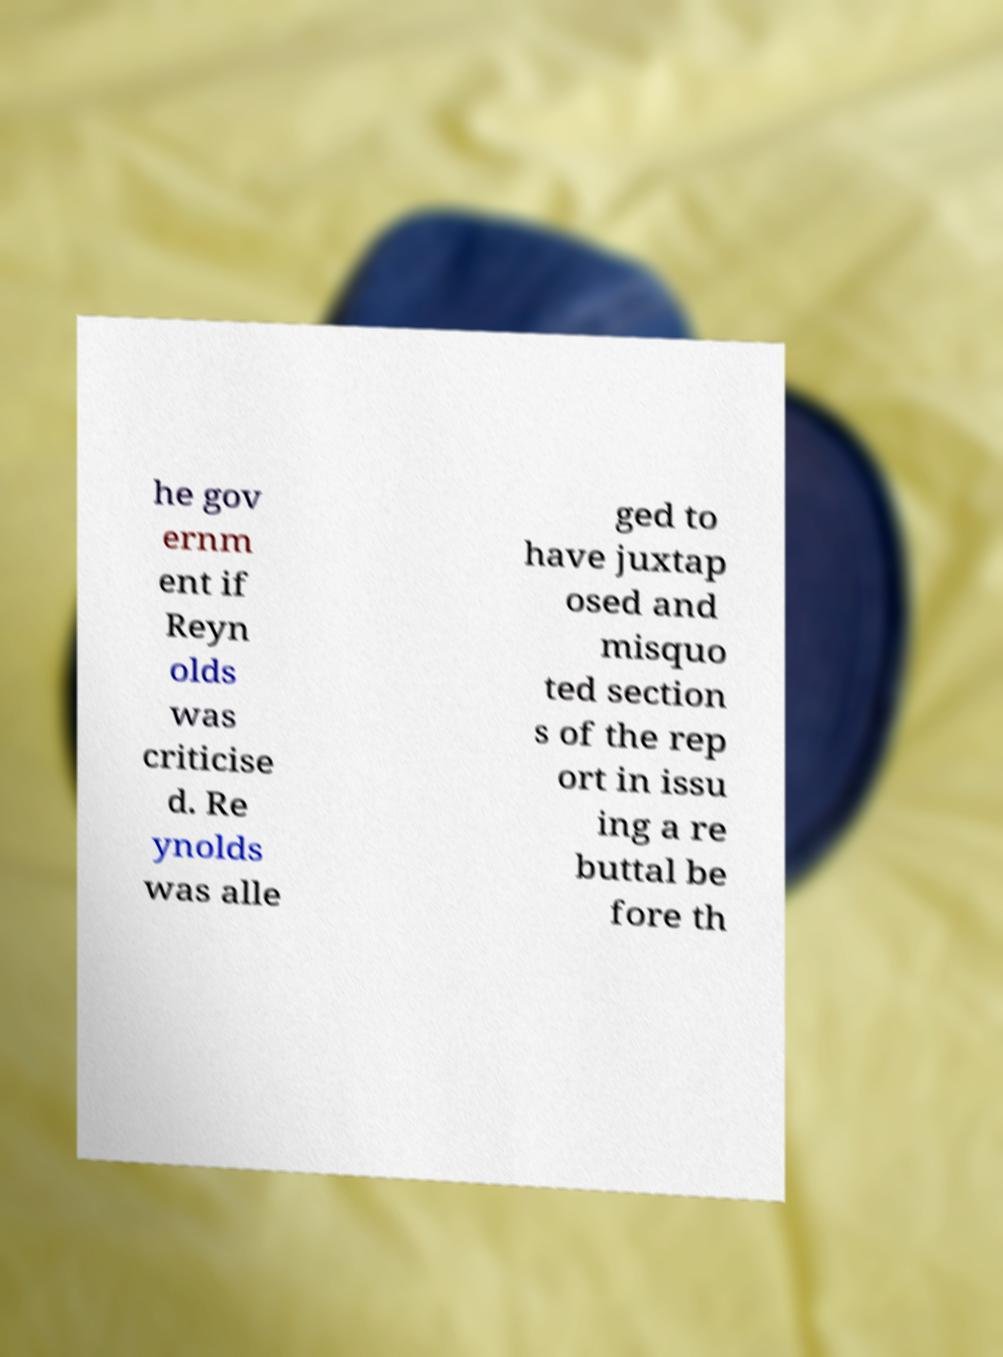What messages or text are displayed in this image? I need them in a readable, typed format. he gov ernm ent if Reyn olds was criticise d. Re ynolds was alle ged to have juxtap osed and misquo ted section s of the rep ort in issu ing a re buttal be fore th 